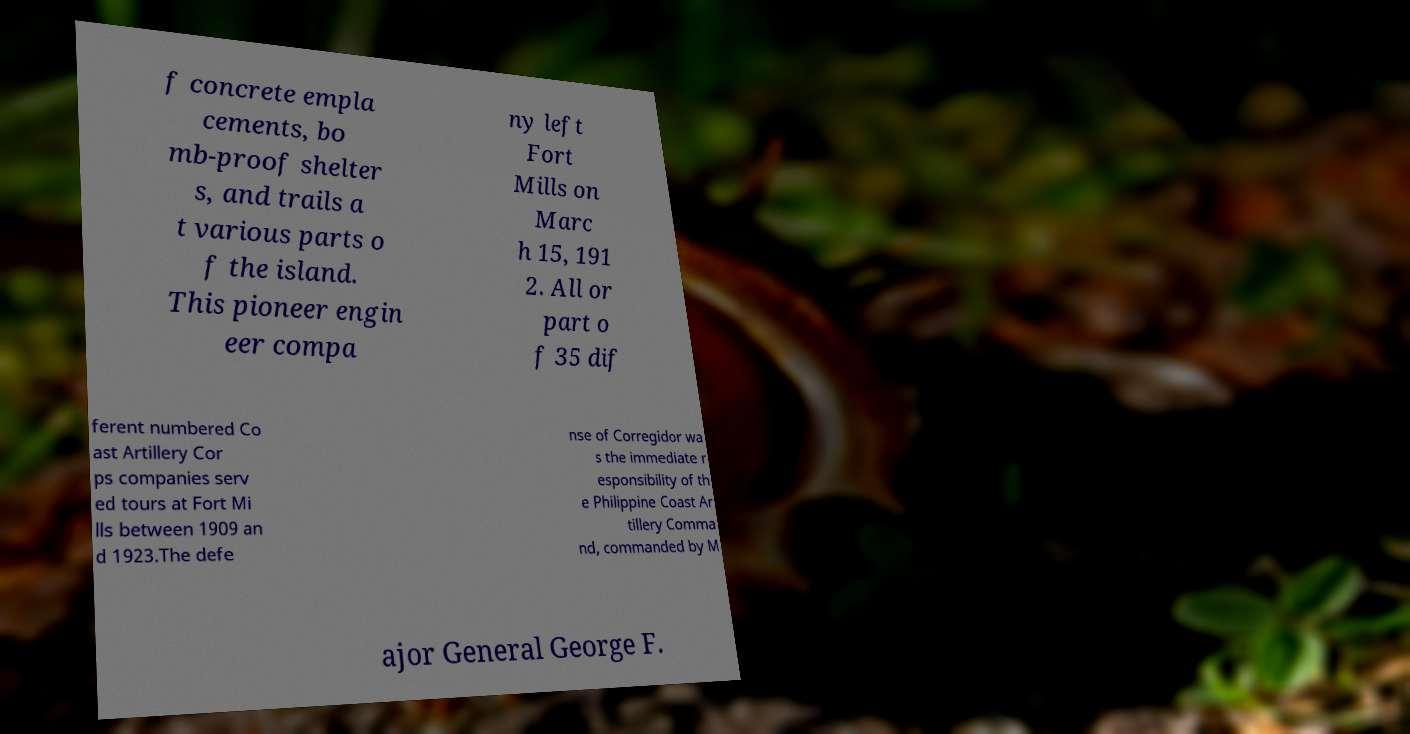There's text embedded in this image that I need extracted. Can you transcribe it verbatim? f concrete empla cements, bo mb-proof shelter s, and trails a t various parts o f the island. This pioneer engin eer compa ny left Fort Mills on Marc h 15, 191 2. All or part o f 35 dif ferent numbered Co ast Artillery Cor ps companies serv ed tours at Fort Mi lls between 1909 an d 1923.The defe nse of Corregidor wa s the immediate r esponsibility of th e Philippine Coast Ar tillery Comma nd, commanded by M ajor General George F. 